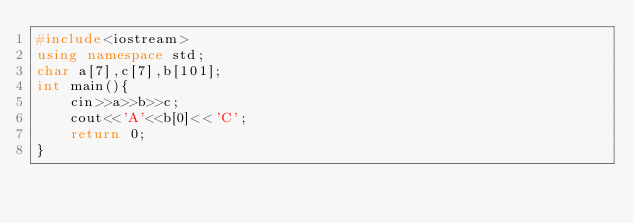<code> <loc_0><loc_0><loc_500><loc_500><_C++_>#include<iostream>
using namespace std;
char a[7],c[7],b[101];
int main(){
    cin>>a>>b>>c;
    cout<<'A'<<b[0]<<'C';
    return 0;
}</code> 